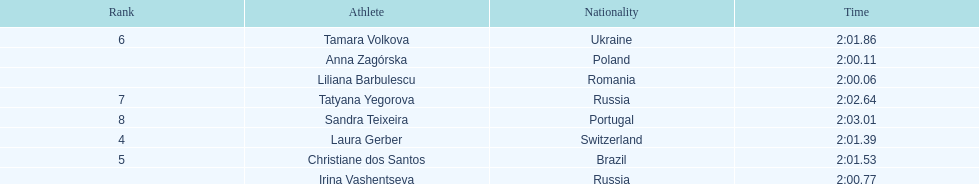Which country had the most finishers in the top 8? Russia. 